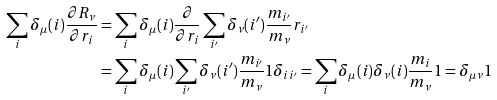<formula> <loc_0><loc_0><loc_500><loc_500>\sum _ { i } \delta _ { \mu } ( i ) \frac { \partial { R } _ { \nu } } { \partial { r } _ { i } } & = \sum _ { i } \delta _ { \mu } ( i ) \frac { \partial } { \partial { r } _ { i } } \sum _ { i ^ { \prime } } \delta _ { \nu } ( i ^ { \prime } ) \frac { m _ { i ^ { \prime } } } { m _ { \nu } } { r } _ { i ^ { \prime } } \\ & = \sum _ { i } \delta _ { \mu } ( i ) \sum _ { i ^ { \prime } } \delta _ { \nu } ( i ^ { \prime } ) \frac { m _ { i ^ { \prime } } } { m _ { \nu } } { 1 } \delta _ { i i ^ { \prime } } = \sum _ { i } \delta _ { \mu } ( i ) \delta _ { \nu } ( i ) \frac { m _ { i } } { m _ { \nu } } { 1 } = \delta _ { \mu \nu } { 1 }</formula> 